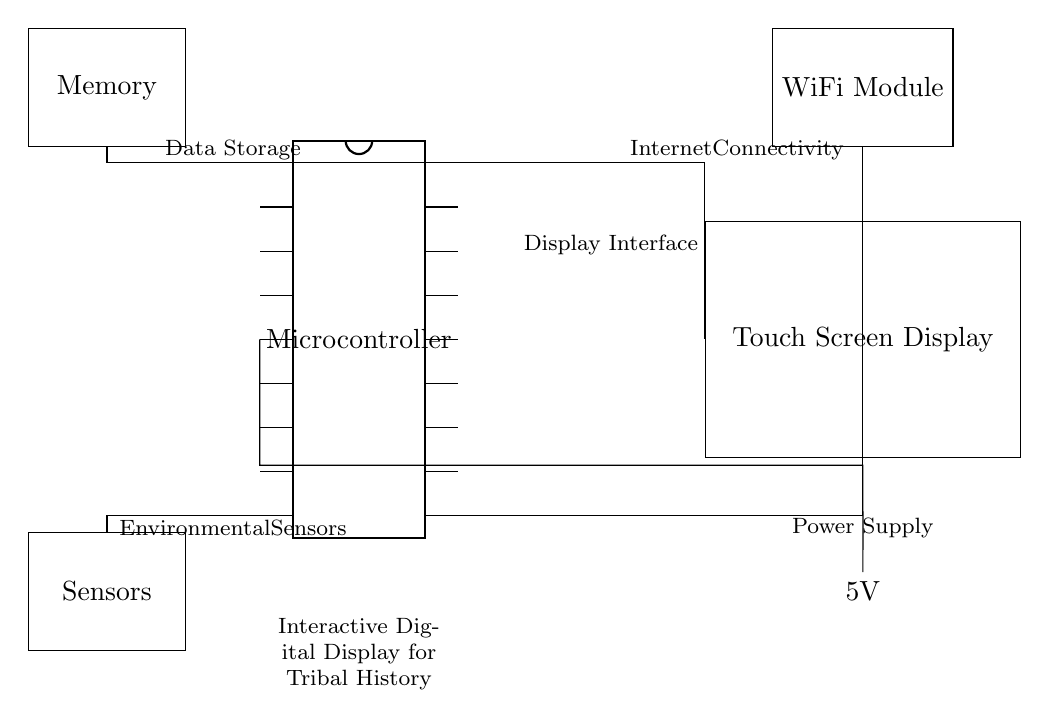What is the main component shown in the circuit? The main component in the circuit is a microcontroller, which is represented as a DIP chip with 18 pins. It serves as the central processing unit for the interactive digital display.
Answer: microcontroller What is the function of the touch screen display? The touch screen display is the user interface where users can interact with the electronic system to showcase tribal history and artifacts. It allows users to navigate through the information presented.
Answer: user interface How many pins does the microcontroller have? The microcontroller in the circuit has 18 pins, as indicated in the diagram. This is a typical configuration for many microcontroller packages.
Answer: 18 What type of power supply is used in this circuit? The circuit uses a 5V battery as the power supply, shown as a battery symbol connected to the microcontroller. The voltage rating is marked, indicating the potential supplied to the circuit.
Answer: 5V Which component is used for internet connectivity? The component used for internet connectivity in this circuit is a WiFi module, which allows the microcontroller to connect to networks. This functionality is vital for accessing online resources or remote data.
Answer: WiFi module What is the role of the memory module in this circuit? The memory module is used for data storage, where it holds information related to tribal history and artifacts that the display shows. It connects to the microcontroller to facilitate data retrieval and updates.
Answer: data storage What do the environmental sensors detect in this circuit? The environmental sensors in this circuit are likely to monitor conditions such as temperature, humidity, or light, which can enhance the presentation of tribal artifacts by providing contextual information based on real-world environmental conditions.
Answer: monitoring conditions 